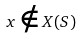<formula> <loc_0><loc_0><loc_500><loc_500>x \notin X ( S )</formula> 